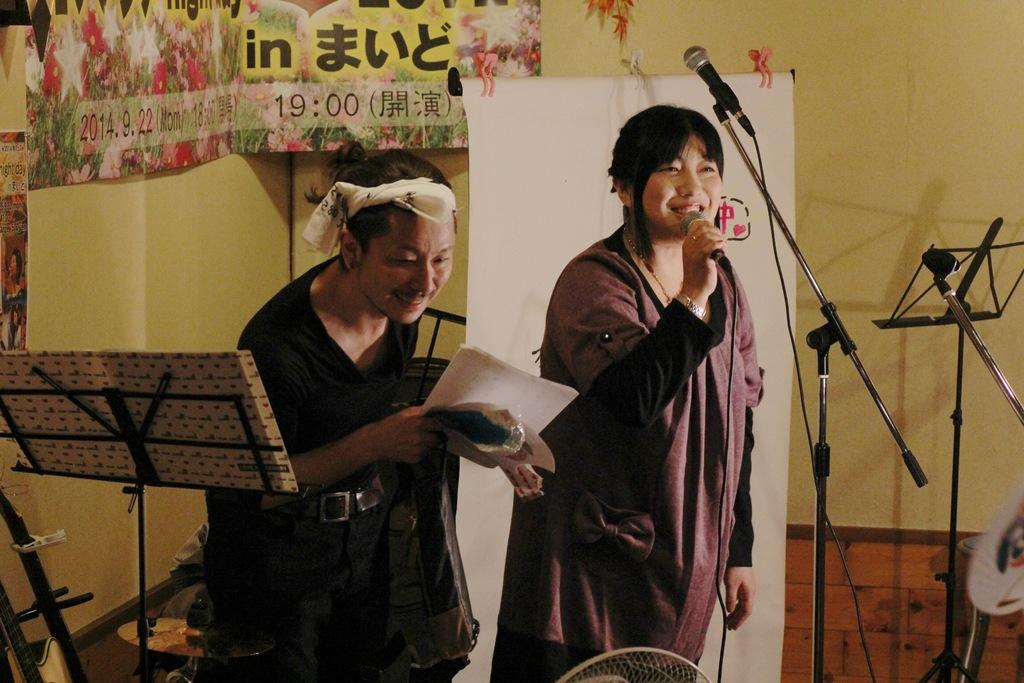How many people are in the image? There are two persons standing in the image. What is the woman holding in the image? The woman is holding a mic. What can be seen at the back side of the image? There is a banner and a wall at the back side of the image. What type of mountain can be seen in the background of the image? There is no mountain visible in the image; it features two people, a woman holding a mic, and a banner and wall at the back side. 